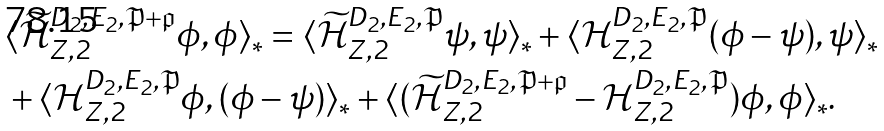Convert formula to latex. <formula><loc_0><loc_0><loc_500><loc_500>& \langle \widetilde { \mathcal { H } } _ { Z , 2 } ^ { D _ { 2 } , E _ { 2 } , \mathfrak { P } + \mathfrak { p } } \phi , \phi \rangle _ { * } = \langle \widetilde { \mathcal { H } } _ { Z , 2 } ^ { D _ { 2 } , E _ { 2 } , \mathfrak { P } } \psi , \psi \rangle _ { * } + \langle \mathcal { H } _ { Z , 2 } ^ { D _ { 2 } , E _ { 2 } , \mathfrak { P } } ( \phi - \psi ) , \psi \rangle _ { * } \\ & + \langle \mathcal { H } _ { Z , 2 } ^ { D _ { 2 } , E _ { 2 } , \mathfrak { P } } \phi , ( \phi - \psi ) \rangle _ { * } + \langle ( \widetilde { \mathcal { H } } _ { Z , 2 } ^ { D _ { 2 } , E _ { 2 } , \mathfrak { P } + \mathfrak { p } } - \mathcal { H } _ { Z , 2 } ^ { D _ { 2 } , E _ { 2 } , \mathfrak { P } } ) \phi , \phi \rangle _ { * } .</formula> 